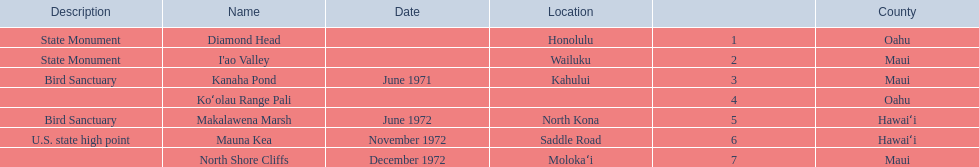How many locations are bird sanctuaries. 2. 